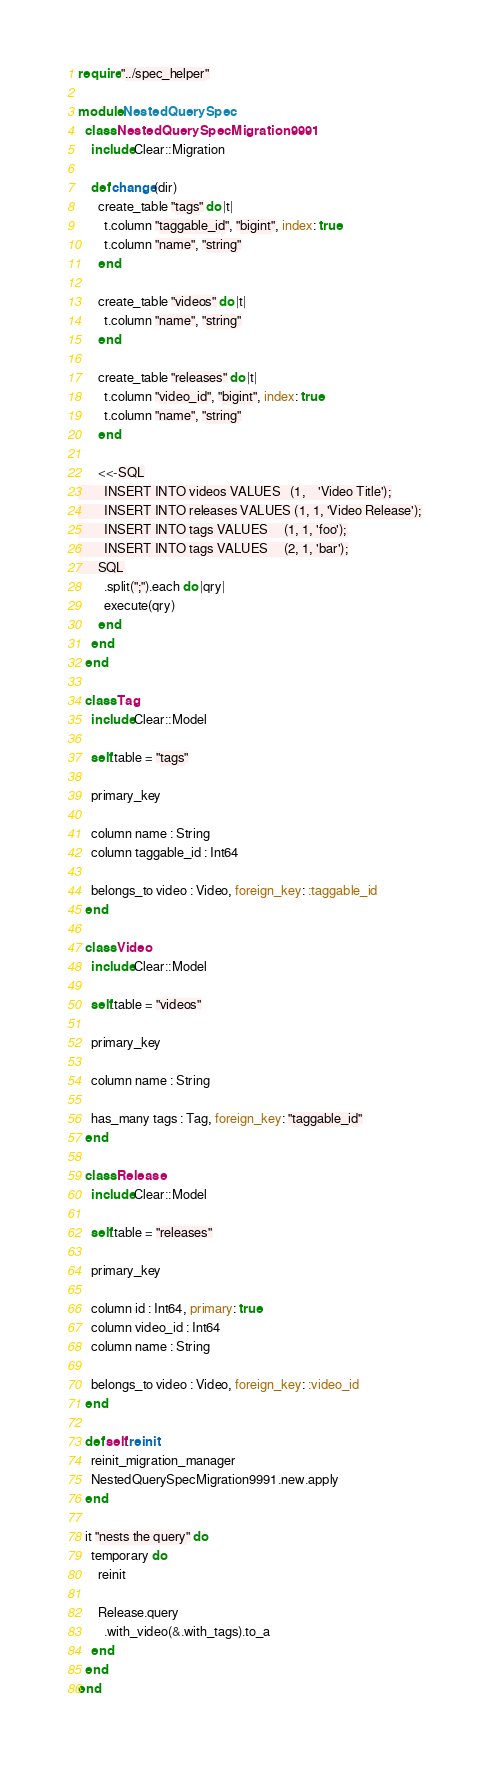Convert code to text. <code><loc_0><loc_0><loc_500><loc_500><_Crystal_>require "../spec_helper"

module NestedQuerySpec
  class NestedQuerySpecMigration9991
    include Clear::Migration

    def change(dir)
      create_table "tags" do |t|
        t.column "taggable_id", "bigint", index: true
        t.column "name", "string"
      end

      create_table "videos" do |t|
        t.column "name", "string"
      end

      create_table "releases" do |t|
        t.column "video_id", "bigint", index: true
        t.column "name", "string"
      end

      <<-SQL
        INSERT INTO videos VALUES   (1,    'Video Title');
        INSERT INTO releases VALUES (1, 1, 'Video Release');
        INSERT INTO tags VALUES     (1, 1, 'foo');
        INSERT INTO tags VALUES     (2, 1, 'bar');
      SQL
        .split(";").each do |qry|
        execute(qry)
      end
    end
  end

  class Tag
    include Clear::Model

    self.table = "tags"

    primary_key

    column name : String
    column taggable_id : Int64

    belongs_to video : Video, foreign_key: :taggable_id
  end

  class Video
    include Clear::Model

    self.table = "videos"

    primary_key

    column name : String

    has_many tags : Tag, foreign_key: "taggable_id"
  end

  class Release
    include Clear::Model

    self.table = "releases"

    primary_key

    column id : Int64, primary: true
    column video_id : Int64
    column name : String

    belongs_to video : Video, foreign_key: :video_id
  end

  def self.reinit
    reinit_migration_manager
    NestedQuerySpecMigration9991.new.apply
  end

  it "nests the query" do
    temporary do
      reinit

      Release.query
        .with_video(&.with_tags).to_a
    end
  end
end
</code> 